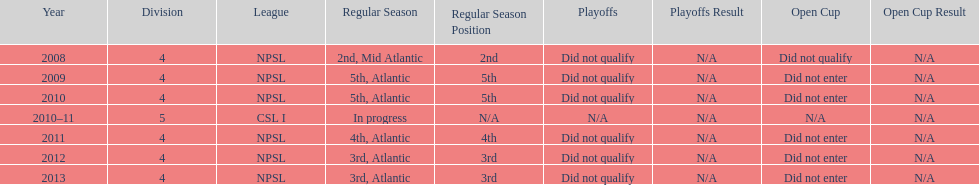Give me the full table as a dictionary. {'header': ['Year', 'Division', 'League', 'Regular Season', 'Regular Season Position', 'Playoffs', 'Playoffs Result', 'Open Cup', 'Open Cup Result'], 'rows': [['2008', '4', 'NPSL', '2nd, Mid Atlantic', '2nd', 'Did not qualify', 'N/A', 'Did not qualify', 'N/A'], ['2009', '4', 'NPSL', '5th, Atlantic', '5th', 'Did not qualify', 'N/A', 'Did not enter', 'N/A'], ['2010', '4', 'NPSL', '5th, Atlantic', '5th', 'Did not qualify', 'N/A', 'Did not enter', 'N/A'], ['2010–11', '5', 'CSL I', 'In progress', 'N/A', 'N/A', 'N/A', 'N/A', 'N/A'], ['2011', '4', 'NPSL', '4th, Atlantic', '4th', 'Did not qualify', 'N/A', 'Did not enter', 'N/A'], ['2012', '4', 'NPSL', '3rd, Atlantic', '3rd', 'Did not qualify', 'N/A', 'Did not enter', 'N/A'], ['2013', '4', 'NPSL', '3rd, Atlantic', '3rd', 'Did not qualify', 'N/A', 'Did not enter', 'N/A']]} Which year was more successful, 2010 or 2013? 2013. 